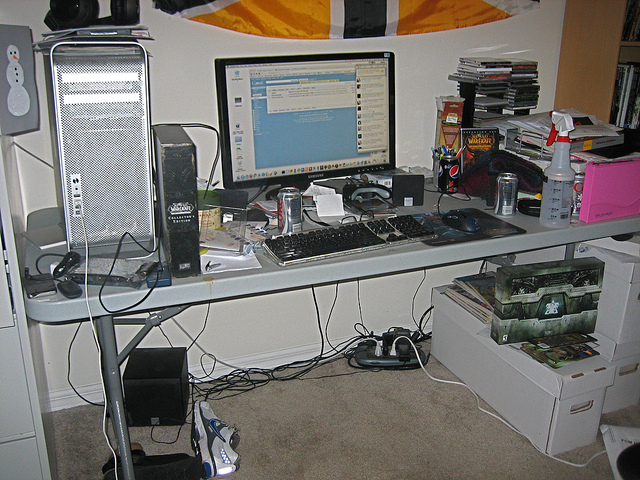<image>What breath freshener is on the desk? There is no breath freshener on the desk. Who makes this type of computer? I don't know who makes this type of computer. It could be Dell, Hewlett Packard, Compaq, or a custom build. What kind of computers are there? I am not sure what kind of computers are there. They could be windows, dell, compaq, hp, desktop or mac. What breath freshener is on the desk? I don't know what breath freshener is on the desk. It is not visible in the image. Who makes this type of computer? I don't know who makes this type of computer. It can be Dell, Hewlett Packard, Compaq, or a custom build. What kind of computers are there? I don't know what kind of computers are there. It can be seen 'windows', 'dell', 'desktop', 'compaq', 'hp', 'mac' or others. 